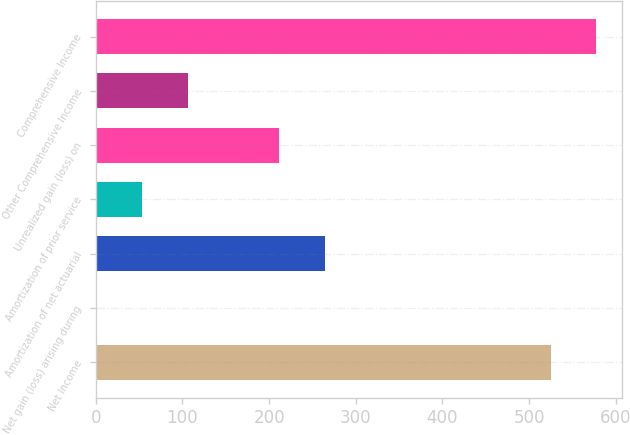Convert chart. <chart><loc_0><loc_0><loc_500><loc_500><bar_chart><fcel>Net Income<fcel>Net gain (loss) arising during<fcel>Amortization of net actuarial<fcel>Amortization of prior service<fcel>Unrealized gain (loss) on<fcel>Other Comprehensive Income<fcel>Comprehensive Income<nl><fcel>525<fcel>1<fcel>264<fcel>53.6<fcel>211.4<fcel>106.2<fcel>577.6<nl></chart> 